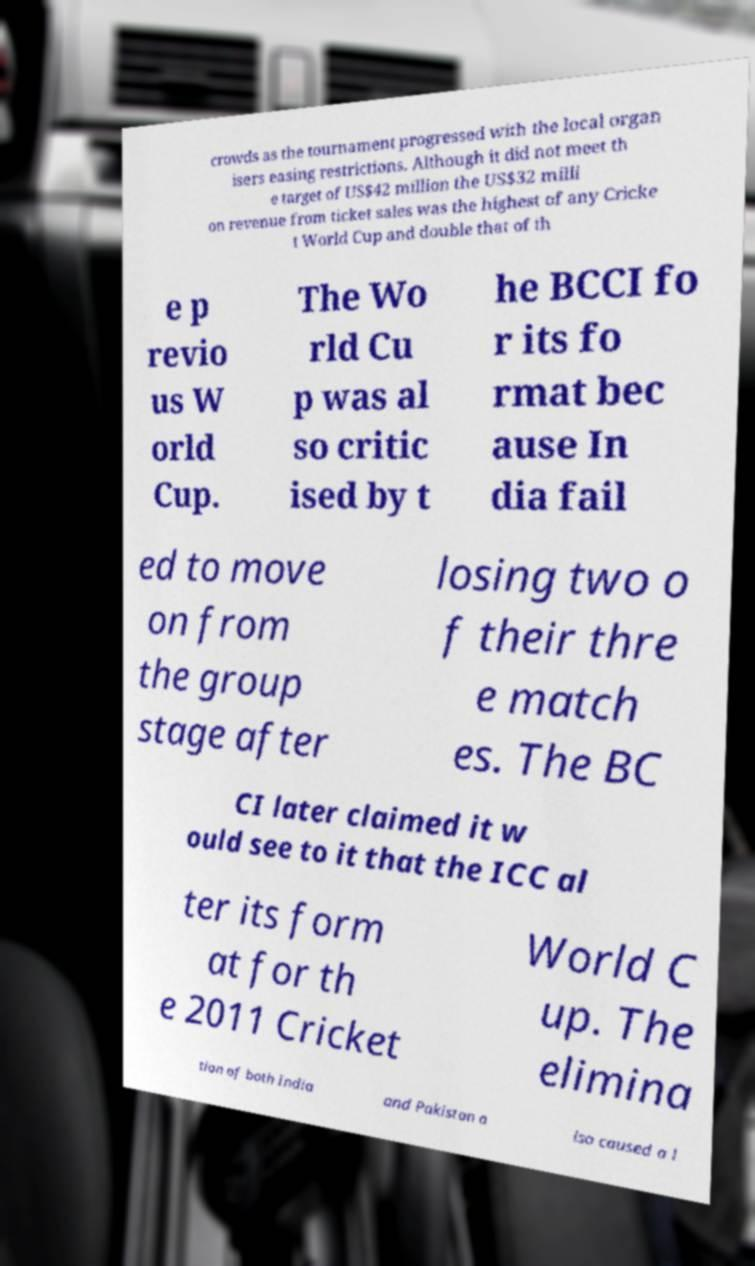Please identify and transcribe the text found in this image. crowds as the tournament progressed with the local organ isers easing restrictions. Although it did not meet th e target of US$42 million the US$32 milli on revenue from ticket sales was the highest of any Cricke t World Cup and double that of th e p revio us W orld Cup. The Wo rld Cu p was al so critic ised by t he BCCI fo r its fo rmat bec ause In dia fail ed to move on from the group stage after losing two o f their thre e match es. The BC CI later claimed it w ould see to it that the ICC al ter its form at for th e 2011 Cricket World C up. The elimina tion of both India and Pakistan a lso caused a l 